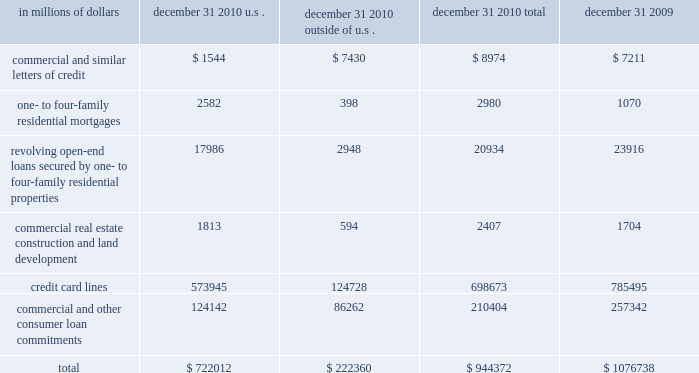Credit commitments and lines of credit the table below summarizes citigroup 2019s credit commitments as of december 31 , 2010 and december 31 , 2009: .
The majority of unused commitments are contingent upon customers maintaining specific credit standards .
Commercial commitments generally have floating interest rates and fixed expiration dates and may require payment of fees .
Such fees ( net of certain direct costs ) are deferred and , upon exercise of the commitment , amortized over the life of the loan or , if exercise is deemed remote , amortized over the commitment period .
Commercial and similar letters of credit a commercial letter of credit is an instrument by which citigroup substitutes its credit for that of a customer to enable the customer to finance the purchase of goods or to incur other commitments .
Citigroup issues a letter on behalf of its client to a supplier and agrees to pay the supplier upon presentation of documentary evidence that the supplier has performed in accordance with the terms of the letter of credit .
When a letter of credit is drawn , the customer is then required to reimburse citigroup .
One- to four-family residential mortgages a one- to four-family residential mortgage commitment is a written confirmation from citigroup to a seller of a property that the bank will advance the specified sums enabling the buyer to complete the purchase .
Revolving open-end loans secured by one- to four-family residential properties revolving open-end loans secured by one- to four-family residential properties are essentially home equity lines of credit .
A home equity line of credit is a loan secured by a primary residence or second home to the extent of the excess of fair market value over the debt outstanding for the first mortgage .
Commercial real estate , construction and land development commercial real estate , construction and land development include unused portions of commitments to extend credit for the purpose of financing commercial and multifamily residential properties as well as land development projects .
Both secured-by-real-estate and unsecured commitments are included in this line , as well as undistributed loan proceeds , where there is an obligation to advance for construction progress payments .
However , this line only includes those extensions of credit that , once funded , will be classified as loans on the consolidated balance sheet .
Credit card lines citigroup provides credit to customers by issuing credit cards .
The credit card lines are unconditionally cancelable by the issuer .
Commercial and other consumer loan commitments commercial and other consumer loan commitments include overdraft and liquidity facilities , as well as commercial commitments to make or purchase loans , to purchase third-party receivables , to provide note issuance or revolving underwriting facilities and to invest in the form of equity .
Amounts include $ 79 billion and $ 126 billion with an original maturity of less than one year at december 31 , 2010 and december 31 , 2009 , respectively .
In addition , included in this line item are highly leveraged financing commitments , which are agreements that provide funding to a borrower with higher levels of debt ( measured by the ratio of debt capital to equity capital of the borrower ) than is generally considered normal for other companies .
This type of financing is commonly employed in corporate acquisitions , management buy-outs and similar transactions. .
What percentage of citigroup 2019s credit commitments as of december 31 , 2010 are outside of the u.s.? 
Computations: (222360 / 944372)
Answer: 0.23546. Credit commitments and lines of credit the table below summarizes citigroup 2019s credit commitments as of december 31 , 2010 and december 31 , 2009: .
The majority of unused commitments are contingent upon customers maintaining specific credit standards .
Commercial commitments generally have floating interest rates and fixed expiration dates and may require payment of fees .
Such fees ( net of certain direct costs ) are deferred and , upon exercise of the commitment , amortized over the life of the loan or , if exercise is deemed remote , amortized over the commitment period .
Commercial and similar letters of credit a commercial letter of credit is an instrument by which citigroup substitutes its credit for that of a customer to enable the customer to finance the purchase of goods or to incur other commitments .
Citigroup issues a letter on behalf of its client to a supplier and agrees to pay the supplier upon presentation of documentary evidence that the supplier has performed in accordance with the terms of the letter of credit .
When a letter of credit is drawn , the customer is then required to reimburse citigroup .
One- to four-family residential mortgages a one- to four-family residential mortgage commitment is a written confirmation from citigroup to a seller of a property that the bank will advance the specified sums enabling the buyer to complete the purchase .
Revolving open-end loans secured by one- to four-family residential properties revolving open-end loans secured by one- to four-family residential properties are essentially home equity lines of credit .
A home equity line of credit is a loan secured by a primary residence or second home to the extent of the excess of fair market value over the debt outstanding for the first mortgage .
Commercial real estate , construction and land development commercial real estate , construction and land development include unused portions of commitments to extend credit for the purpose of financing commercial and multifamily residential properties as well as land development projects .
Both secured-by-real-estate and unsecured commitments are included in this line , as well as undistributed loan proceeds , where there is an obligation to advance for construction progress payments .
However , this line only includes those extensions of credit that , once funded , will be classified as loans on the consolidated balance sheet .
Credit card lines citigroup provides credit to customers by issuing credit cards .
The credit card lines are unconditionally cancelable by the issuer .
Commercial and other consumer loan commitments commercial and other consumer loan commitments include overdraft and liquidity facilities , as well as commercial commitments to make or purchase loans , to purchase third-party receivables , to provide note issuance or revolving underwriting facilities and to invest in the form of equity .
Amounts include $ 79 billion and $ 126 billion with an original maturity of less than one year at december 31 , 2010 and december 31 , 2009 , respectively .
In addition , included in this line item are highly leveraged financing commitments , which are agreements that provide funding to a borrower with higher levels of debt ( measured by the ratio of debt capital to equity capital of the borrower ) than is generally considered normal for other companies .
This type of financing is commonly employed in corporate acquisitions , management buy-outs and similar transactions. .
What was the percentage of the change in the credit commitments and lines of credit for citigroup 2019s from 2009 to 2010? 
Computations: ((944372 - 1076738) / 1076738)
Answer: -0.12293. 